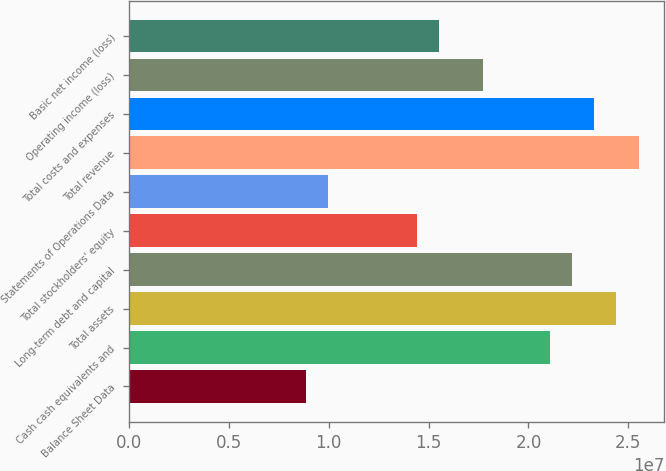Convert chart. <chart><loc_0><loc_0><loc_500><loc_500><bar_chart><fcel>Balance Sheet Data<fcel>Cash cash equivalents and<fcel>Total assets<fcel>Long-term debt and capital<fcel>Total stockholders' equity<fcel>Statements of Operations Data<fcel>Total revenue<fcel>Total costs and expenses<fcel>Operating income (loss)<fcel>Basic net income (loss)<nl><fcel>8.8723e+06<fcel>2.10717e+07<fcel>2.43988e+07<fcel>2.21807e+07<fcel>1.44175e+07<fcel>9.98134e+06<fcel>2.55079e+07<fcel>2.32898e+07<fcel>1.77446e+07<fcel>1.55265e+07<nl></chart> 